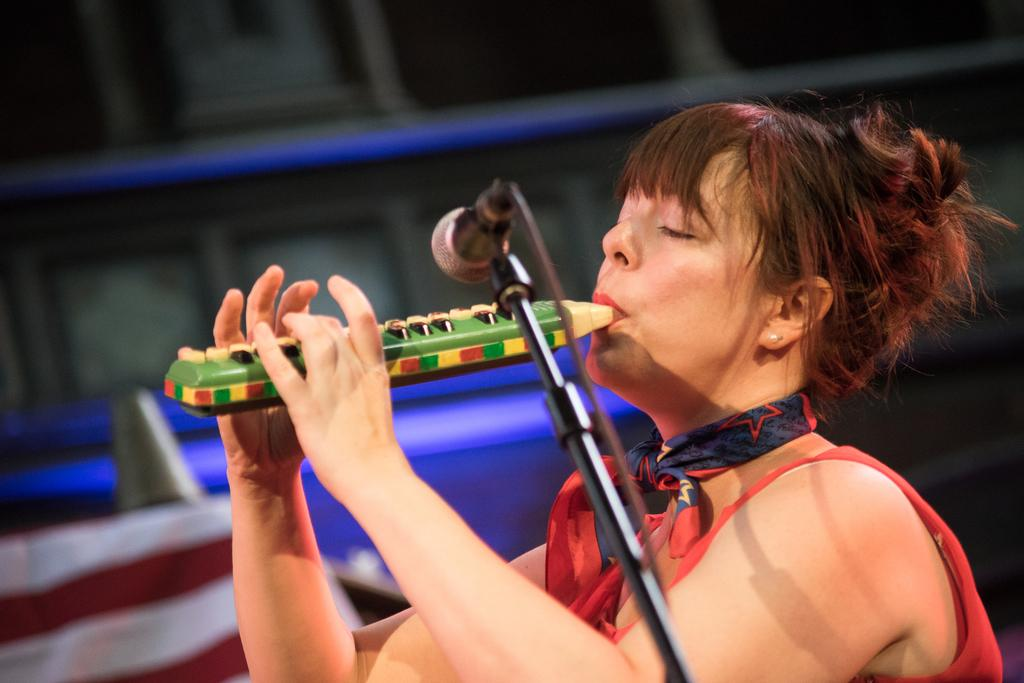Who is the main subject in the image? There is a lady in the image. What is the lady doing in the image? The lady is playing a musical instrument. What object is present for amplifying her voice? There is a microphone in the image. Can you describe the background of the image? The background of the image is blurred. How many passengers are sitting on the sofa in the image? There is no sofa or passengers present in the image. 